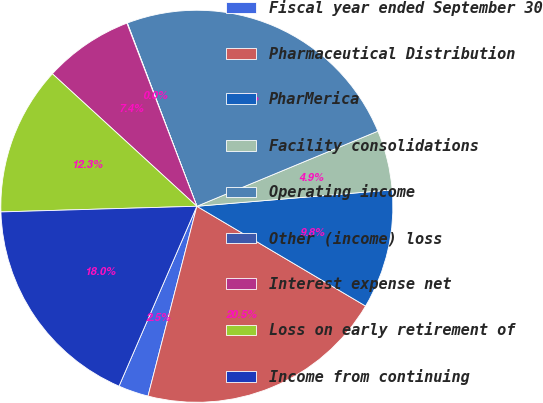Convert chart. <chart><loc_0><loc_0><loc_500><loc_500><pie_chart><fcel>Fiscal year ended September 30<fcel>Pharmaceutical Distribution<fcel>PharMerica<fcel>Facility consolidations<fcel>Operating income<fcel>Other (income) loss<fcel>Interest expense net<fcel>Loss on early retirement of<fcel>Income from continuing<nl><fcel>2.49%<fcel>20.51%<fcel>9.83%<fcel>4.93%<fcel>24.51%<fcel>0.04%<fcel>7.38%<fcel>12.27%<fcel>18.04%<nl></chart> 